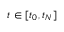<formula> <loc_0><loc_0><loc_500><loc_500>t \in [ t _ { 0 } , t _ { N } ]</formula> 